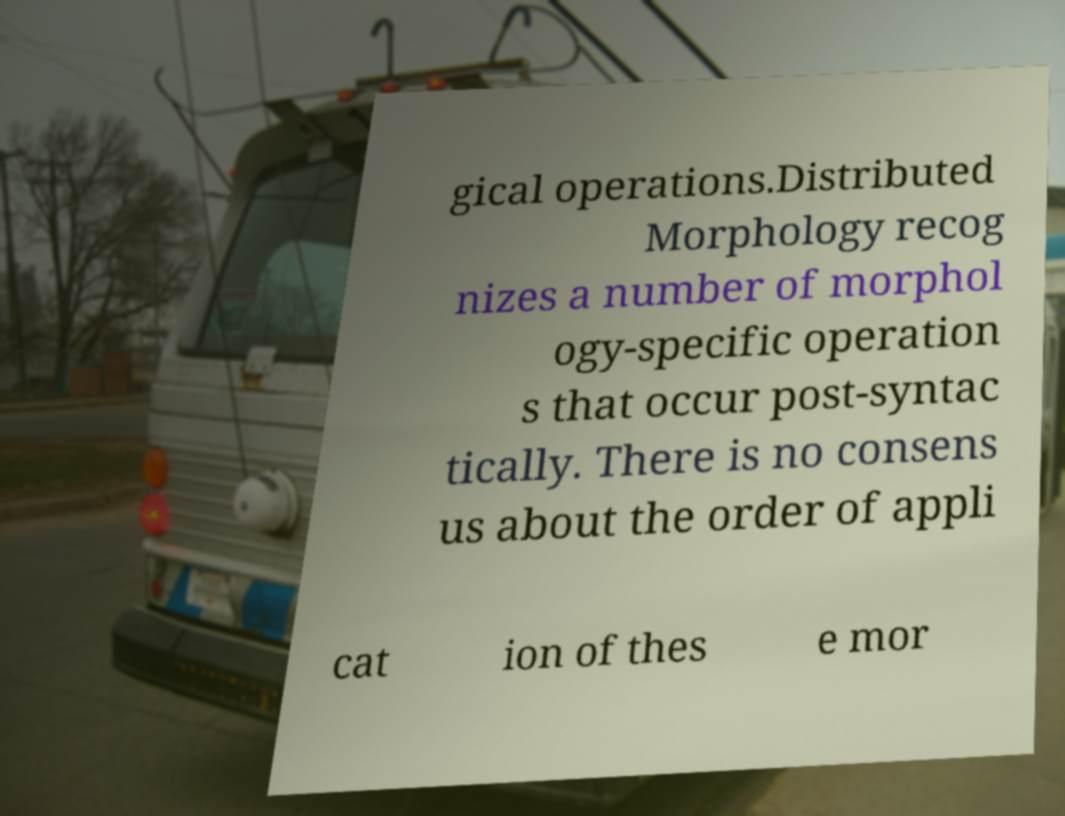I need the written content from this picture converted into text. Can you do that? gical operations.Distributed Morphology recog nizes a number of morphol ogy-specific operation s that occur post-syntac tically. There is no consens us about the order of appli cat ion of thes e mor 